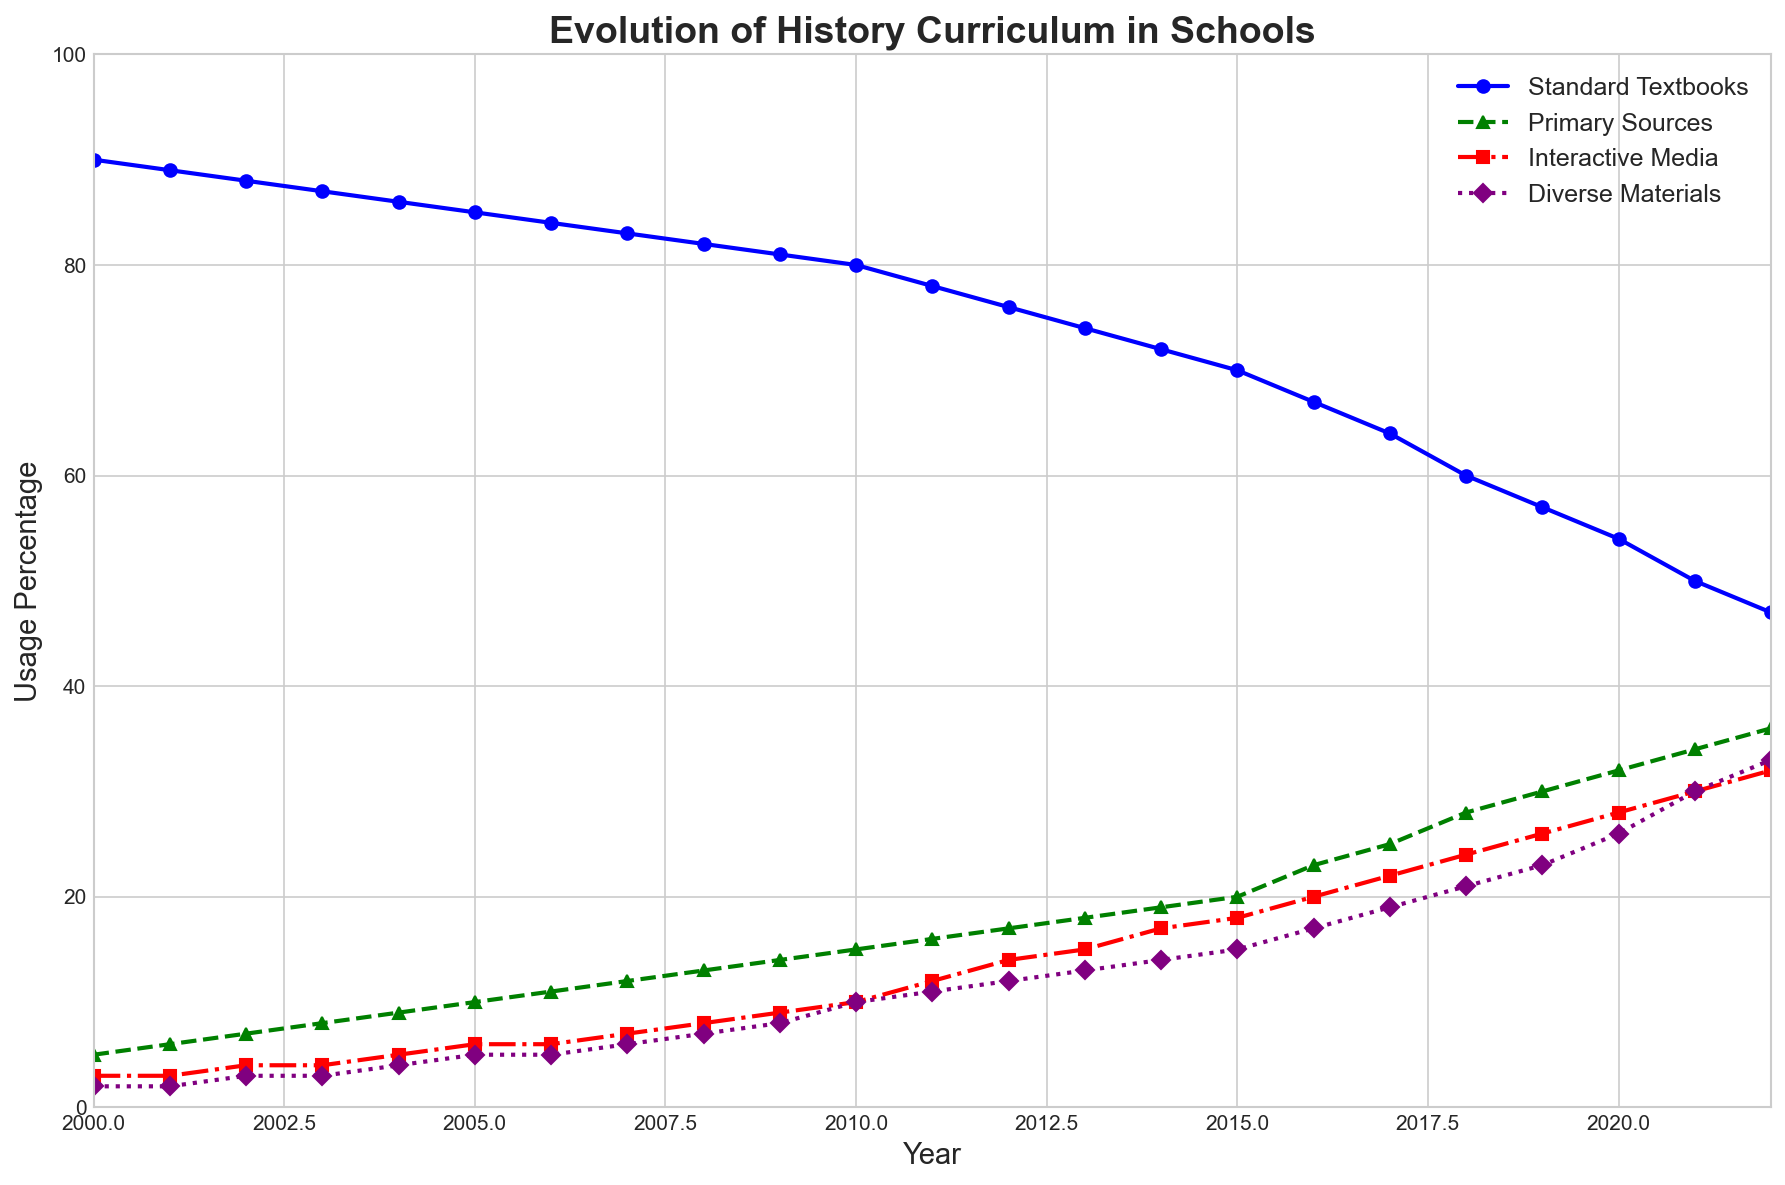How has the percentage usage of primary sources changed from 2000 to 2022? The percentage usage of primary sources can be seen as increasing from 5% in 2000 to 36% in 2022. So the change is 36 - 5 = 31.
Answer: Increased by 31% Which educational material had the highest percentage usage in 2000 and in 2022? In 2000, standard textbooks had the highest usage at 90%. In 2022, the usage of the standard textbooks dropped, but still remained the highest with 47%.
Answer: Standard textbooks What is the trend in the usage of standard textbooks from 2000 to 2022? By observing the line for standard textbooks, we notice a consistent decline from 90% in 2000 to 47% in 2022.
Answer: Declining Compare the usage percentage of interactive media and diverse materials in 2015. In 2015, the usage percentage of interactive media is 18% and diverse materials is 15%. Interactive media usage is higher by 3%.
Answer: Interactive media > Diverse materials What period shows the biggest increase in the usage of interactive media? Viewing the trend of the interactive media line, the largest increase is from 2010 (10%) to 2011 (12%), showing an increase of 2 percentage points.
Answer: 2010 to 2011 What is the difference in the percentage usage of standard textbooks and primary sources in 2020? In 2020, the usage of standard textbooks is 54% and primary sources is 32%. The difference is 54 - 32 = 22.
Answer: 22 Is there any year where the usage of diverse materials surpassed the usage of primary sources? Yes, in 2021 the usage of diverse materials (30%) surpassed the usage of primary sources (34%).
Answer: No Describe the overall trend in the usage of diverse materials from 2000 to 2022. Observing the line for diverse materials, we see a consistent increase from 2% in 2000 to 33% in 2022.
Answer: Increasing Between which two years did the usage percentage of standard textbooks first fall below 50%? The line for standard textbooks first falls below 50% between 2020 (54%) and 2021 (50%).
Answer: 2020 and 2021 